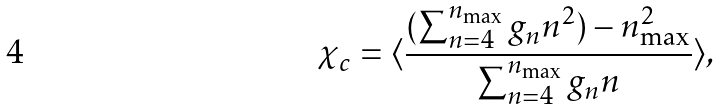Convert formula to latex. <formula><loc_0><loc_0><loc_500><loc_500>\chi _ { c } = \langle \frac { ( \sum _ { n = 4 } ^ { n _ { \max } } g _ { n } n ^ { 2 } ) - n _ { \max } ^ { 2 } } { \sum _ { n = 4 } ^ { n _ { \max } } g _ { n } n } \rangle ,</formula> 